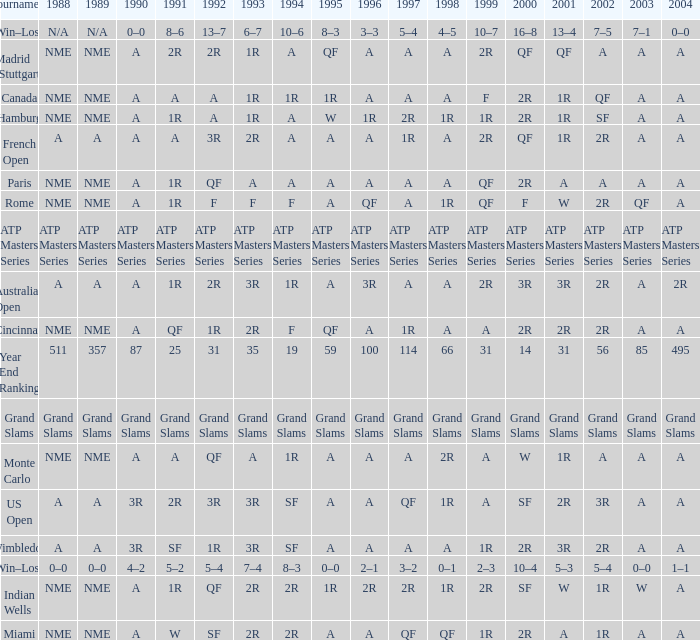Could you parse the entire table? {'header': ['Tournament', '1988', '1989', '1990', '1991', '1992', '1993', '1994', '1995', '1996', '1997', '1998', '1999', '2000', '2001', '2002', '2003', '2004'], 'rows': [['Win–Loss', 'N/A', 'N/A', '0–0', '8–6', '13–7', '6–7', '10–6', '8–3', '3–3', '5–4', '4–5', '10–7', '16–8', '13–4', '7–5', '7–1', '0–0'], ['Madrid (Stuttgart)', 'NME', 'NME', 'A', '2R', '2R', '1R', 'A', 'QF', 'A', 'A', 'A', '2R', 'QF', 'QF', 'A', 'A', 'A'], ['Canada', 'NME', 'NME', 'A', 'A', 'A', '1R', '1R', '1R', 'A', 'A', 'A', 'F', '2R', '1R', 'QF', 'A', 'A'], ['Hamburg', 'NME', 'NME', 'A', '1R', 'A', '1R', 'A', 'W', '1R', '2R', '1R', '1R', '2R', '1R', 'SF', 'A', 'A'], ['French Open', 'A', 'A', 'A', 'A', '3R', '2R', 'A', 'A', 'A', '1R', 'A', '2R', 'QF', '1R', '2R', 'A', 'A'], ['Paris', 'NME', 'NME', 'A', '1R', 'QF', 'A', 'A', 'A', 'A', 'A', 'A', 'QF', '2R', 'A', 'A', 'A', 'A'], ['Rome', 'NME', 'NME', 'A', '1R', 'F', 'F', 'F', 'A', 'QF', 'A', '1R', 'QF', 'F', 'W', '2R', 'QF', 'A'], ['ATP Masters Series', 'ATP Masters Series', 'ATP Masters Series', 'ATP Masters Series', 'ATP Masters Series', 'ATP Masters Series', 'ATP Masters Series', 'ATP Masters Series', 'ATP Masters Series', 'ATP Masters Series', 'ATP Masters Series', 'ATP Masters Series', 'ATP Masters Series', 'ATP Masters Series', 'ATP Masters Series', 'ATP Masters Series', 'ATP Masters Series', 'ATP Masters Series'], ['Australian Open', 'A', 'A', 'A', '1R', '2R', '3R', '1R', 'A', '3R', 'A', 'A', '2R', '3R', '3R', '2R', 'A', '2R'], ['Cincinnati', 'NME', 'NME', 'A', 'QF', '1R', '2R', 'F', 'QF', 'A', '1R', 'A', 'A', '2R', '2R', '2R', 'A', 'A'], ['Year End Ranking', '511', '357', '87', '25', '31', '35', '19', '59', '100', '114', '66', '31', '14', '31', '56', '85', '495'], ['Grand Slams', 'Grand Slams', 'Grand Slams', 'Grand Slams', 'Grand Slams', 'Grand Slams', 'Grand Slams', 'Grand Slams', 'Grand Slams', 'Grand Slams', 'Grand Slams', 'Grand Slams', 'Grand Slams', 'Grand Slams', 'Grand Slams', 'Grand Slams', 'Grand Slams', 'Grand Slams'], ['Monte Carlo', 'NME', 'NME', 'A', 'A', 'QF', 'A', '1R', 'A', 'A', 'A', '2R', 'A', 'W', '1R', 'A', 'A', 'A'], ['US Open', 'A', 'A', '3R', '2R', '3R', '3R', 'SF', 'A', 'A', 'QF', '1R', 'A', 'SF', '2R', '3R', 'A', 'A'], ['Wimbledon', 'A', 'A', '3R', 'SF', '1R', '3R', 'SF', 'A', 'A', 'A', 'A', '1R', '2R', '3R', '2R', 'A', 'A'], ['Win–Loss', '0–0', '0–0', '4–2', '5–2', '5–4', '7–4', '8–3', '0–0', '2–1', '3–2', '0–1', '2–3', '10–4', '5–3', '5–4', '0–0', '1–1'], ['Indian Wells', 'NME', 'NME', 'A', '1R', 'QF', '2R', '2R', '1R', '2R', '2R', '1R', '2R', 'SF', 'W', '1R', 'W', 'A'], ['Miami', 'NME', 'NME', 'A', 'W', 'SF', '2R', '2R', 'A', 'A', 'QF', 'QF', '1R', '2R', 'A', '1R', 'A', 'A']]} What shows for 2002 when the 1991 is w? 1R. 